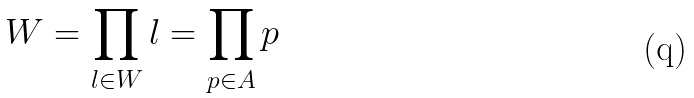Convert formula to latex. <formula><loc_0><loc_0><loc_500><loc_500>W = \prod _ { l \in W } l = \prod _ { p \in A } p</formula> 